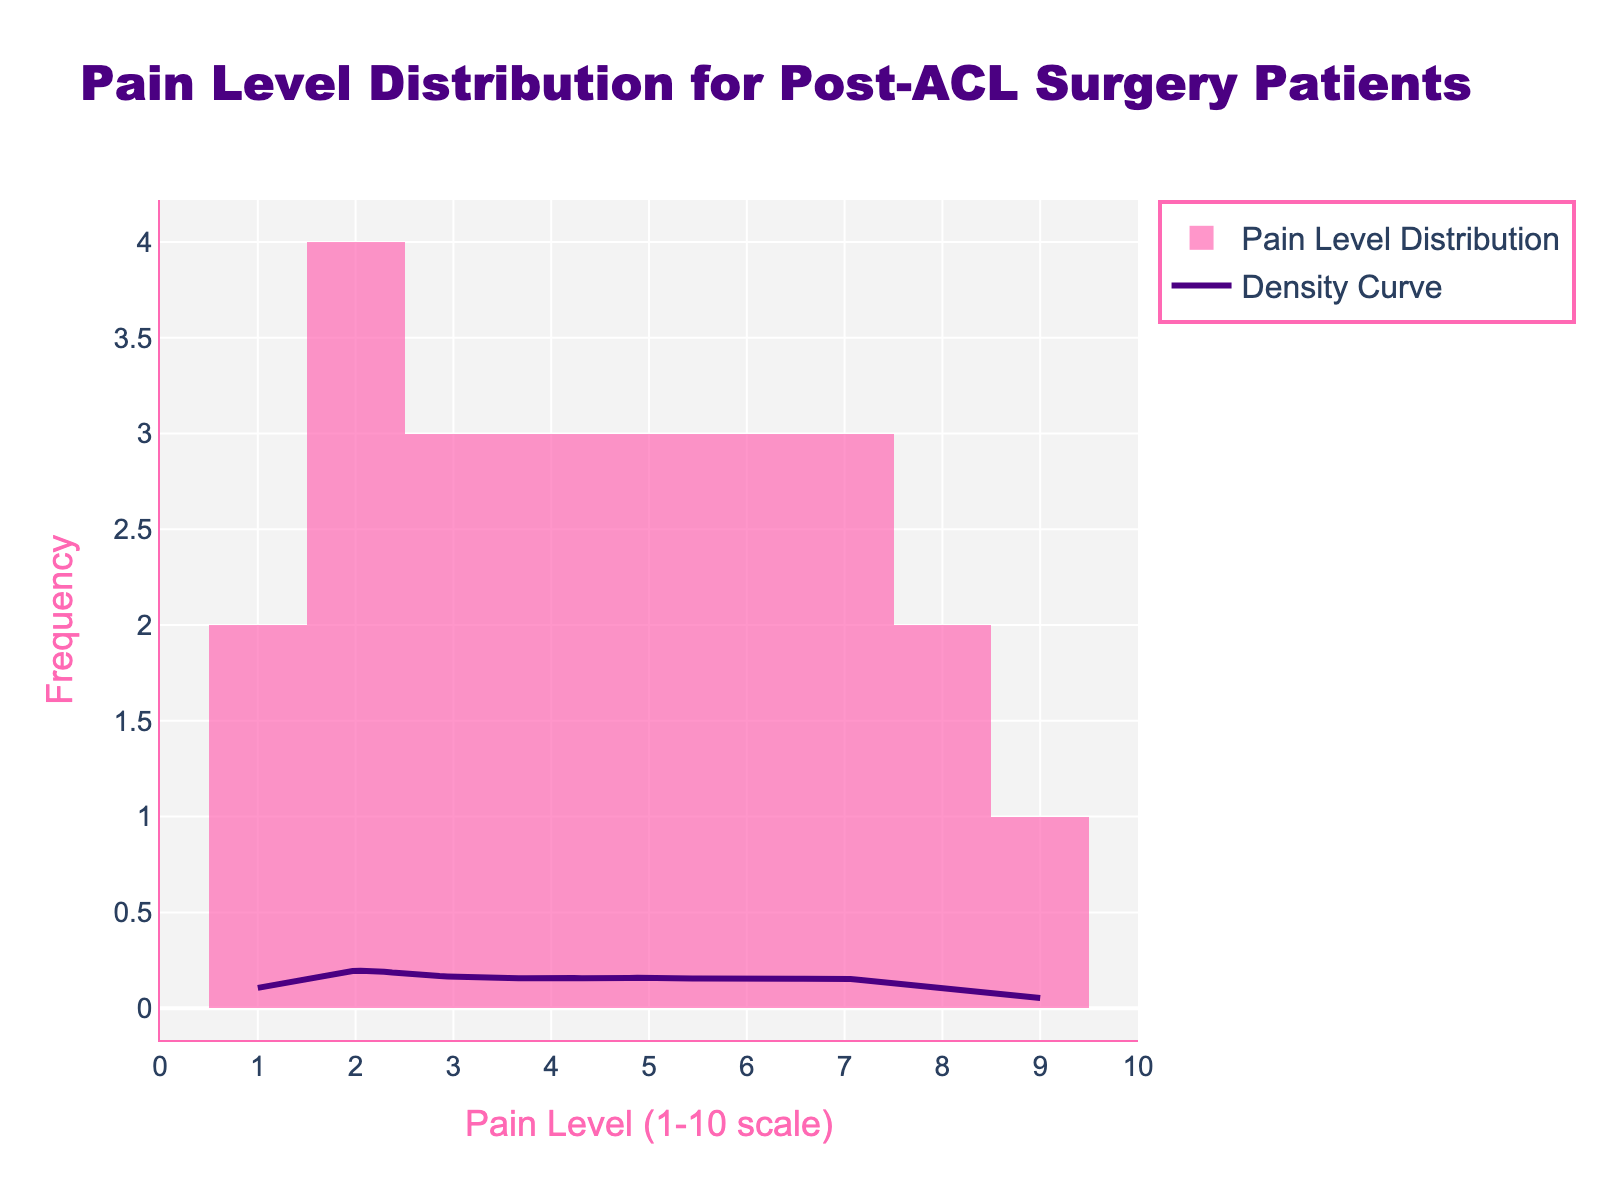what is the range of the x-axis? The x-axis is labeled 'Pain Level (1-10 scale)' and ranges from 0 to 10, as indicated by the x-axis ticks and labels on the plot.
Answer: 0 to 10 what is the y-axis representing? The y-axis is labeled 'Frequency' which indicates the number of occurrences of each pain level in the dataset.
Answer: Frequency what is the pain level that appears most frequently? The tallest bar in the histogram represents the pain level with the highest frequency. In this plot, the bar for pain level 2 is the tallest, indicating it appears most frequently.
Answer: 2 which pain level has the lowest frequency? The shortest bars in the histogram represent the pain levels with the lowest frequency. Here, pain levels 10 and 9 have the lowest frequency as their bars are the shortest.
Answer: 9 and 10 are higher pain levels (8-10) common in this dataset? The histogram shows fewer occurrences of higher pain levels, with only a few bars at pain level 8, and even fewer or none at levels 9 and 10.
Answer: No how does the density curve (KDE) help in understanding the distribution? The Density Curve (KDE) provides a smooth approximation of the overall distribution of the data, making it easier to see trends and peaks compared to the more binned histogram. It shows that most data points are concentrated at lower pain levels.
Answer: It shows the overall trend and concentration of data what is the trend of pain levels over time from the histogram? The histogram shows that the frequency of high pain levels decreases while the frequency of low pain levels increases. This trend indicates an overall reduction in pain levels over time after ACL surgery.
Answer: Decreasing over time how does the highest pain peak on the density curve compare to the histogram? The highest peak on the density curve corresponds to the highest bar in the histogram at pain level 2, indicating that the KDE accurately reflects the concentration of data in the histogram.
Answer: Similar does the histogram suggest that pain levels are spread uniformly across the pain scale? No, the histogram shows more occurrences at lower pain levels (1-4) and fewer at higher pain levels (8-10), suggesting a non-uniform spread with a concentration toward the lower end.
Answer: No, more concentrated at lower levels how would you describe the overall pattern of pain levels in this dataset? The overall pattern indicates a trend of decreasing pain over the first 3 months post-ACL surgery, with higher pain levels initially and lower pain levels as time progresses.
Answer: Decreasing pain over time 